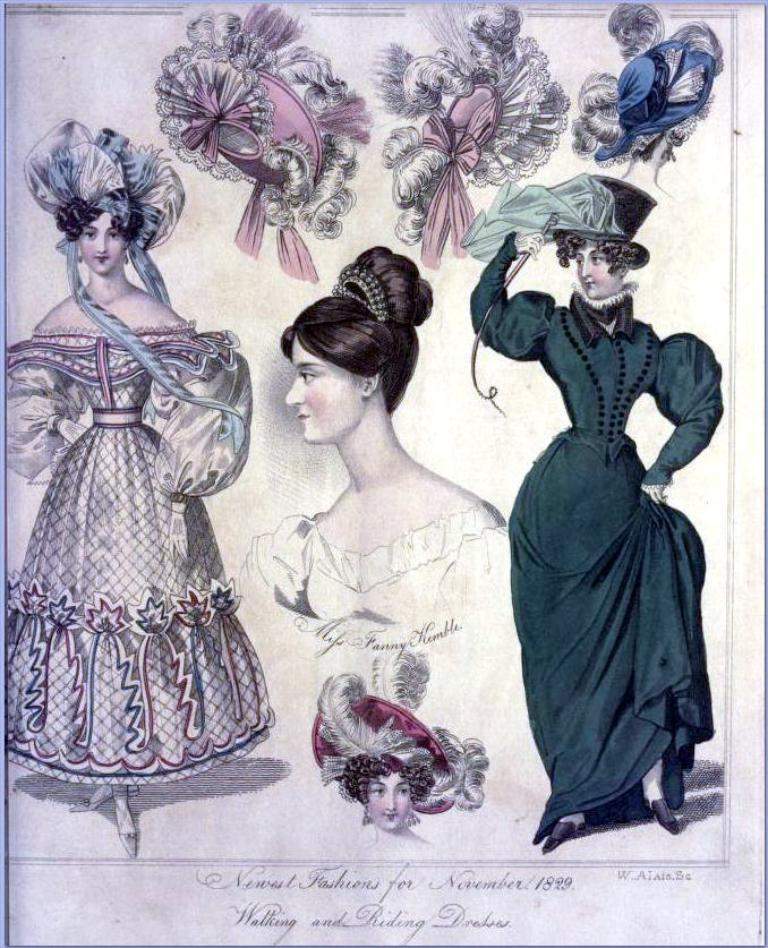What is the main subject of the image? There is a painting in the image. What can be seen in the painting? The painting contains images of women and some objects. Is there any text associated with the painting? Yes, there is text at the bottom of the painting. What type of leather is used to create the balance in the painting? There is no leather or balance present in the painting; it features images of women and objects with text at the bottom. 